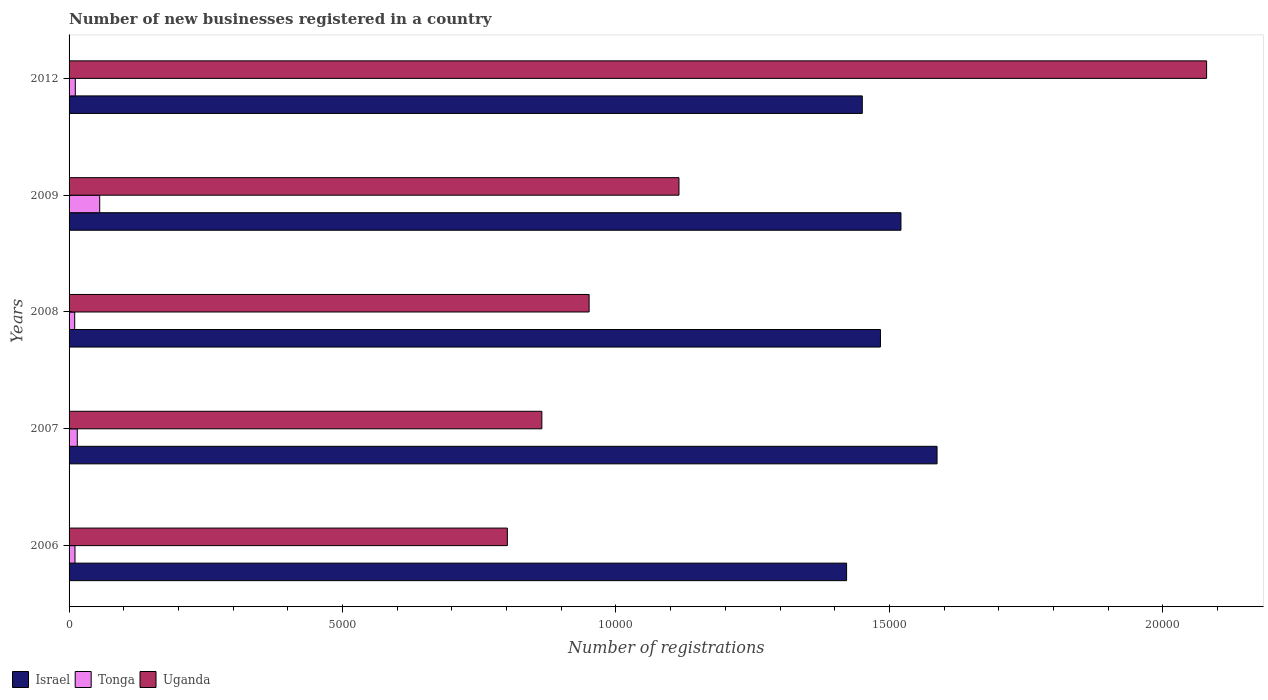How many different coloured bars are there?
Keep it short and to the point. 3. How many groups of bars are there?
Provide a short and direct response. 5. Are the number of bars per tick equal to the number of legend labels?
Keep it short and to the point. Yes. How many bars are there on the 1st tick from the top?
Provide a succinct answer. 3. In how many cases, is the number of bars for a given year not equal to the number of legend labels?
Make the answer very short. 0. What is the number of new businesses registered in Uganda in 2006?
Offer a terse response. 8014. Across all years, what is the maximum number of new businesses registered in Uganda?
Give a very brief answer. 2.08e+04. Across all years, what is the minimum number of new businesses registered in Tonga?
Make the answer very short. 103. What is the total number of new businesses registered in Uganda in the graph?
Give a very brief answer. 5.81e+04. What is the difference between the number of new businesses registered in Uganda in 2007 and that in 2008?
Make the answer very short. -864. What is the difference between the number of new businesses registered in Tonga in 2006 and the number of new businesses registered in Israel in 2009?
Ensure brevity in your answer.  -1.51e+04. What is the average number of new businesses registered in Uganda per year?
Give a very brief answer. 1.16e+04. In the year 2008, what is the difference between the number of new businesses registered in Uganda and number of new businesses registered in Tonga?
Your answer should be compact. 9406. What is the ratio of the number of new businesses registered in Tonga in 2006 to that in 2007?
Offer a terse response. 0.72. Is the difference between the number of new businesses registered in Uganda in 2007 and 2012 greater than the difference between the number of new businesses registered in Tonga in 2007 and 2012?
Provide a succinct answer. No. What is the difference between the highest and the second highest number of new businesses registered in Israel?
Keep it short and to the point. 660. What is the difference between the highest and the lowest number of new businesses registered in Tonga?
Offer a terse response. 457. In how many years, is the number of new businesses registered in Israel greater than the average number of new businesses registered in Israel taken over all years?
Ensure brevity in your answer.  2. What does the 2nd bar from the top in 2007 represents?
Make the answer very short. Tonga. What does the 1st bar from the bottom in 2012 represents?
Your answer should be compact. Israel. How many bars are there?
Offer a terse response. 15. Are all the bars in the graph horizontal?
Your answer should be very brief. Yes. How many years are there in the graph?
Keep it short and to the point. 5. What is the difference between two consecutive major ticks on the X-axis?
Ensure brevity in your answer.  5000. Are the values on the major ticks of X-axis written in scientific E-notation?
Offer a very short reply. No. Does the graph contain grids?
Offer a terse response. No. Where does the legend appear in the graph?
Offer a terse response. Bottom left. How many legend labels are there?
Keep it short and to the point. 3. How are the legend labels stacked?
Your answer should be compact. Horizontal. What is the title of the graph?
Make the answer very short. Number of new businesses registered in a country. What is the label or title of the X-axis?
Your answer should be compact. Number of registrations. What is the label or title of the Y-axis?
Keep it short and to the point. Years. What is the Number of registrations in Israel in 2006?
Your answer should be compact. 1.42e+04. What is the Number of registrations of Tonga in 2006?
Provide a short and direct response. 108. What is the Number of registrations of Uganda in 2006?
Keep it short and to the point. 8014. What is the Number of registrations in Israel in 2007?
Offer a terse response. 1.59e+04. What is the Number of registrations in Tonga in 2007?
Keep it short and to the point. 150. What is the Number of registrations of Uganda in 2007?
Keep it short and to the point. 8645. What is the Number of registrations of Israel in 2008?
Make the answer very short. 1.48e+04. What is the Number of registrations in Tonga in 2008?
Your answer should be very brief. 103. What is the Number of registrations in Uganda in 2008?
Your response must be concise. 9509. What is the Number of registrations in Israel in 2009?
Your answer should be compact. 1.52e+04. What is the Number of registrations in Tonga in 2009?
Your answer should be very brief. 560. What is the Number of registrations of Uganda in 2009?
Provide a short and direct response. 1.12e+04. What is the Number of registrations in Israel in 2012?
Your answer should be compact. 1.45e+04. What is the Number of registrations in Tonga in 2012?
Ensure brevity in your answer.  114. What is the Number of registrations of Uganda in 2012?
Keep it short and to the point. 2.08e+04. Across all years, what is the maximum Number of registrations of Israel?
Give a very brief answer. 1.59e+04. Across all years, what is the maximum Number of registrations in Tonga?
Provide a short and direct response. 560. Across all years, what is the maximum Number of registrations of Uganda?
Provide a short and direct response. 2.08e+04. Across all years, what is the minimum Number of registrations in Israel?
Provide a succinct answer. 1.42e+04. Across all years, what is the minimum Number of registrations in Tonga?
Offer a very short reply. 103. Across all years, what is the minimum Number of registrations in Uganda?
Keep it short and to the point. 8014. What is the total Number of registrations in Israel in the graph?
Your answer should be very brief. 7.46e+04. What is the total Number of registrations in Tonga in the graph?
Your response must be concise. 1035. What is the total Number of registrations in Uganda in the graph?
Your answer should be very brief. 5.81e+04. What is the difference between the Number of registrations in Israel in 2006 and that in 2007?
Offer a very short reply. -1654. What is the difference between the Number of registrations of Tonga in 2006 and that in 2007?
Provide a succinct answer. -42. What is the difference between the Number of registrations in Uganda in 2006 and that in 2007?
Provide a short and direct response. -631. What is the difference between the Number of registrations in Israel in 2006 and that in 2008?
Offer a very short reply. -619. What is the difference between the Number of registrations in Tonga in 2006 and that in 2008?
Your answer should be compact. 5. What is the difference between the Number of registrations of Uganda in 2006 and that in 2008?
Your answer should be very brief. -1495. What is the difference between the Number of registrations of Israel in 2006 and that in 2009?
Give a very brief answer. -994. What is the difference between the Number of registrations of Tonga in 2006 and that in 2009?
Provide a succinct answer. -452. What is the difference between the Number of registrations of Uganda in 2006 and that in 2009?
Offer a terse response. -3138. What is the difference between the Number of registrations of Israel in 2006 and that in 2012?
Provide a short and direct response. -287. What is the difference between the Number of registrations in Tonga in 2006 and that in 2012?
Ensure brevity in your answer.  -6. What is the difference between the Number of registrations in Uganda in 2006 and that in 2012?
Your response must be concise. -1.28e+04. What is the difference between the Number of registrations of Israel in 2007 and that in 2008?
Offer a terse response. 1035. What is the difference between the Number of registrations of Uganda in 2007 and that in 2008?
Your answer should be very brief. -864. What is the difference between the Number of registrations in Israel in 2007 and that in 2009?
Make the answer very short. 660. What is the difference between the Number of registrations in Tonga in 2007 and that in 2009?
Your answer should be compact. -410. What is the difference between the Number of registrations in Uganda in 2007 and that in 2009?
Make the answer very short. -2507. What is the difference between the Number of registrations of Israel in 2007 and that in 2012?
Provide a short and direct response. 1367. What is the difference between the Number of registrations in Tonga in 2007 and that in 2012?
Offer a terse response. 36. What is the difference between the Number of registrations in Uganda in 2007 and that in 2012?
Provide a succinct answer. -1.22e+04. What is the difference between the Number of registrations in Israel in 2008 and that in 2009?
Your answer should be very brief. -375. What is the difference between the Number of registrations in Tonga in 2008 and that in 2009?
Make the answer very short. -457. What is the difference between the Number of registrations in Uganda in 2008 and that in 2009?
Your answer should be compact. -1643. What is the difference between the Number of registrations of Israel in 2008 and that in 2012?
Your response must be concise. 332. What is the difference between the Number of registrations of Uganda in 2008 and that in 2012?
Give a very brief answer. -1.13e+04. What is the difference between the Number of registrations of Israel in 2009 and that in 2012?
Your response must be concise. 707. What is the difference between the Number of registrations of Tonga in 2009 and that in 2012?
Provide a succinct answer. 446. What is the difference between the Number of registrations in Uganda in 2009 and that in 2012?
Ensure brevity in your answer.  -9648. What is the difference between the Number of registrations of Israel in 2006 and the Number of registrations of Tonga in 2007?
Your response must be concise. 1.41e+04. What is the difference between the Number of registrations in Israel in 2006 and the Number of registrations in Uganda in 2007?
Offer a terse response. 5572. What is the difference between the Number of registrations in Tonga in 2006 and the Number of registrations in Uganda in 2007?
Offer a terse response. -8537. What is the difference between the Number of registrations of Israel in 2006 and the Number of registrations of Tonga in 2008?
Give a very brief answer. 1.41e+04. What is the difference between the Number of registrations of Israel in 2006 and the Number of registrations of Uganda in 2008?
Your answer should be compact. 4708. What is the difference between the Number of registrations of Tonga in 2006 and the Number of registrations of Uganda in 2008?
Provide a succinct answer. -9401. What is the difference between the Number of registrations of Israel in 2006 and the Number of registrations of Tonga in 2009?
Your answer should be very brief. 1.37e+04. What is the difference between the Number of registrations in Israel in 2006 and the Number of registrations in Uganda in 2009?
Your answer should be very brief. 3065. What is the difference between the Number of registrations of Tonga in 2006 and the Number of registrations of Uganda in 2009?
Provide a short and direct response. -1.10e+04. What is the difference between the Number of registrations in Israel in 2006 and the Number of registrations in Tonga in 2012?
Ensure brevity in your answer.  1.41e+04. What is the difference between the Number of registrations in Israel in 2006 and the Number of registrations in Uganda in 2012?
Keep it short and to the point. -6583. What is the difference between the Number of registrations of Tonga in 2006 and the Number of registrations of Uganda in 2012?
Make the answer very short. -2.07e+04. What is the difference between the Number of registrations of Israel in 2007 and the Number of registrations of Tonga in 2008?
Your answer should be very brief. 1.58e+04. What is the difference between the Number of registrations of Israel in 2007 and the Number of registrations of Uganda in 2008?
Ensure brevity in your answer.  6362. What is the difference between the Number of registrations in Tonga in 2007 and the Number of registrations in Uganda in 2008?
Offer a terse response. -9359. What is the difference between the Number of registrations in Israel in 2007 and the Number of registrations in Tonga in 2009?
Your response must be concise. 1.53e+04. What is the difference between the Number of registrations of Israel in 2007 and the Number of registrations of Uganda in 2009?
Offer a very short reply. 4719. What is the difference between the Number of registrations in Tonga in 2007 and the Number of registrations in Uganda in 2009?
Provide a succinct answer. -1.10e+04. What is the difference between the Number of registrations in Israel in 2007 and the Number of registrations in Tonga in 2012?
Provide a short and direct response. 1.58e+04. What is the difference between the Number of registrations in Israel in 2007 and the Number of registrations in Uganda in 2012?
Your answer should be compact. -4929. What is the difference between the Number of registrations of Tonga in 2007 and the Number of registrations of Uganda in 2012?
Ensure brevity in your answer.  -2.06e+04. What is the difference between the Number of registrations in Israel in 2008 and the Number of registrations in Tonga in 2009?
Your response must be concise. 1.43e+04. What is the difference between the Number of registrations of Israel in 2008 and the Number of registrations of Uganda in 2009?
Provide a short and direct response. 3684. What is the difference between the Number of registrations in Tonga in 2008 and the Number of registrations in Uganda in 2009?
Offer a very short reply. -1.10e+04. What is the difference between the Number of registrations of Israel in 2008 and the Number of registrations of Tonga in 2012?
Ensure brevity in your answer.  1.47e+04. What is the difference between the Number of registrations of Israel in 2008 and the Number of registrations of Uganda in 2012?
Provide a short and direct response. -5964. What is the difference between the Number of registrations of Tonga in 2008 and the Number of registrations of Uganda in 2012?
Give a very brief answer. -2.07e+04. What is the difference between the Number of registrations in Israel in 2009 and the Number of registrations in Tonga in 2012?
Your answer should be very brief. 1.51e+04. What is the difference between the Number of registrations of Israel in 2009 and the Number of registrations of Uganda in 2012?
Your response must be concise. -5589. What is the difference between the Number of registrations in Tonga in 2009 and the Number of registrations in Uganda in 2012?
Your response must be concise. -2.02e+04. What is the average Number of registrations of Israel per year?
Provide a short and direct response. 1.49e+04. What is the average Number of registrations of Tonga per year?
Provide a short and direct response. 207. What is the average Number of registrations of Uganda per year?
Make the answer very short. 1.16e+04. In the year 2006, what is the difference between the Number of registrations of Israel and Number of registrations of Tonga?
Your response must be concise. 1.41e+04. In the year 2006, what is the difference between the Number of registrations in Israel and Number of registrations in Uganda?
Give a very brief answer. 6203. In the year 2006, what is the difference between the Number of registrations in Tonga and Number of registrations in Uganda?
Make the answer very short. -7906. In the year 2007, what is the difference between the Number of registrations of Israel and Number of registrations of Tonga?
Make the answer very short. 1.57e+04. In the year 2007, what is the difference between the Number of registrations of Israel and Number of registrations of Uganda?
Your response must be concise. 7226. In the year 2007, what is the difference between the Number of registrations in Tonga and Number of registrations in Uganda?
Your response must be concise. -8495. In the year 2008, what is the difference between the Number of registrations in Israel and Number of registrations in Tonga?
Your answer should be compact. 1.47e+04. In the year 2008, what is the difference between the Number of registrations in Israel and Number of registrations in Uganda?
Make the answer very short. 5327. In the year 2008, what is the difference between the Number of registrations in Tonga and Number of registrations in Uganda?
Offer a very short reply. -9406. In the year 2009, what is the difference between the Number of registrations of Israel and Number of registrations of Tonga?
Your response must be concise. 1.47e+04. In the year 2009, what is the difference between the Number of registrations of Israel and Number of registrations of Uganda?
Keep it short and to the point. 4059. In the year 2009, what is the difference between the Number of registrations in Tonga and Number of registrations in Uganda?
Keep it short and to the point. -1.06e+04. In the year 2012, what is the difference between the Number of registrations in Israel and Number of registrations in Tonga?
Your answer should be very brief. 1.44e+04. In the year 2012, what is the difference between the Number of registrations in Israel and Number of registrations in Uganda?
Provide a succinct answer. -6296. In the year 2012, what is the difference between the Number of registrations in Tonga and Number of registrations in Uganda?
Your response must be concise. -2.07e+04. What is the ratio of the Number of registrations of Israel in 2006 to that in 2007?
Your response must be concise. 0.9. What is the ratio of the Number of registrations of Tonga in 2006 to that in 2007?
Your answer should be very brief. 0.72. What is the ratio of the Number of registrations in Uganda in 2006 to that in 2007?
Ensure brevity in your answer.  0.93. What is the ratio of the Number of registrations in Tonga in 2006 to that in 2008?
Provide a succinct answer. 1.05. What is the ratio of the Number of registrations in Uganda in 2006 to that in 2008?
Ensure brevity in your answer.  0.84. What is the ratio of the Number of registrations in Israel in 2006 to that in 2009?
Your response must be concise. 0.93. What is the ratio of the Number of registrations in Tonga in 2006 to that in 2009?
Provide a succinct answer. 0.19. What is the ratio of the Number of registrations in Uganda in 2006 to that in 2009?
Your answer should be compact. 0.72. What is the ratio of the Number of registrations of Israel in 2006 to that in 2012?
Ensure brevity in your answer.  0.98. What is the ratio of the Number of registrations in Tonga in 2006 to that in 2012?
Offer a terse response. 0.95. What is the ratio of the Number of registrations of Uganda in 2006 to that in 2012?
Ensure brevity in your answer.  0.39. What is the ratio of the Number of registrations of Israel in 2007 to that in 2008?
Offer a terse response. 1.07. What is the ratio of the Number of registrations in Tonga in 2007 to that in 2008?
Provide a short and direct response. 1.46. What is the ratio of the Number of registrations in Uganda in 2007 to that in 2008?
Your response must be concise. 0.91. What is the ratio of the Number of registrations of Israel in 2007 to that in 2009?
Keep it short and to the point. 1.04. What is the ratio of the Number of registrations of Tonga in 2007 to that in 2009?
Keep it short and to the point. 0.27. What is the ratio of the Number of registrations of Uganda in 2007 to that in 2009?
Offer a terse response. 0.78. What is the ratio of the Number of registrations in Israel in 2007 to that in 2012?
Make the answer very short. 1.09. What is the ratio of the Number of registrations of Tonga in 2007 to that in 2012?
Provide a short and direct response. 1.32. What is the ratio of the Number of registrations in Uganda in 2007 to that in 2012?
Offer a very short reply. 0.42. What is the ratio of the Number of registrations of Israel in 2008 to that in 2009?
Offer a terse response. 0.98. What is the ratio of the Number of registrations of Tonga in 2008 to that in 2009?
Offer a terse response. 0.18. What is the ratio of the Number of registrations of Uganda in 2008 to that in 2009?
Your answer should be compact. 0.85. What is the ratio of the Number of registrations in Israel in 2008 to that in 2012?
Keep it short and to the point. 1.02. What is the ratio of the Number of registrations of Tonga in 2008 to that in 2012?
Give a very brief answer. 0.9. What is the ratio of the Number of registrations in Uganda in 2008 to that in 2012?
Your answer should be very brief. 0.46. What is the ratio of the Number of registrations of Israel in 2009 to that in 2012?
Keep it short and to the point. 1.05. What is the ratio of the Number of registrations of Tonga in 2009 to that in 2012?
Your response must be concise. 4.91. What is the ratio of the Number of registrations in Uganda in 2009 to that in 2012?
Your response must be concise. 0.54. What is the difference between the highest and the second highest Number of registrations in Israel?
Your answer should be very brief. 660. What is the difference between the highest and the second highest Number of registrations of Tonga?
Your response must be concise. 410. What is the difference between the highest and the second highest Number of registrations of Uganda?
Give a very brief answer. 9648. What is the difference between the highest and the lowest Number of registrations of Israel?
Your answer should be compact. 1654. What is the difference between the highest and the lowest Number of registrations in Tonga?
Ensure brevity in your answer.  457. What is the difference between the highest and the lowest Number of registrations of Uganda?
Your answer should be very brief. 1.28e+04. 